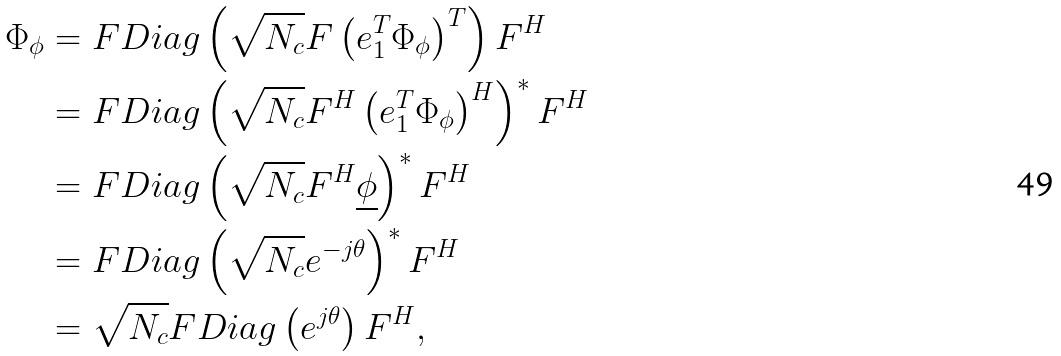<formula> <loc_0><loc_0><loc_500><loc_500>\Phi _ { \phi } & = F D i a g \left ( \sqrt { N _ { c } } F \left ( e _ { 1 } ^ { T } \Phi _ { \phi } \right ) ^ { T } \right ) F ^ { H } \\ & = F D i a g \left ( \sqrt { N _ { c } } F ^ { H } \left ( e _ { 1 } ^ { T } \Phi _ { \phi } \right ) ^ { H } \right ) ^ { \ast } F ^ { H } \\ & = F D i a g \left ( \sqrt { N _ { c } } F ^ { H } \underline { \phi } \right ) ^ { \ast } F ^ { H } \\ & = F D i a g \left ( \sqrt { N _ { c } } e ^ { - j \theta } \right ) ^ { \ast } F ^ { H } \\ & = \sqrt { N _ { c } } F D i a g \left ( e ^ { j \theta } \right ) F ^ { H } ,</formula> 